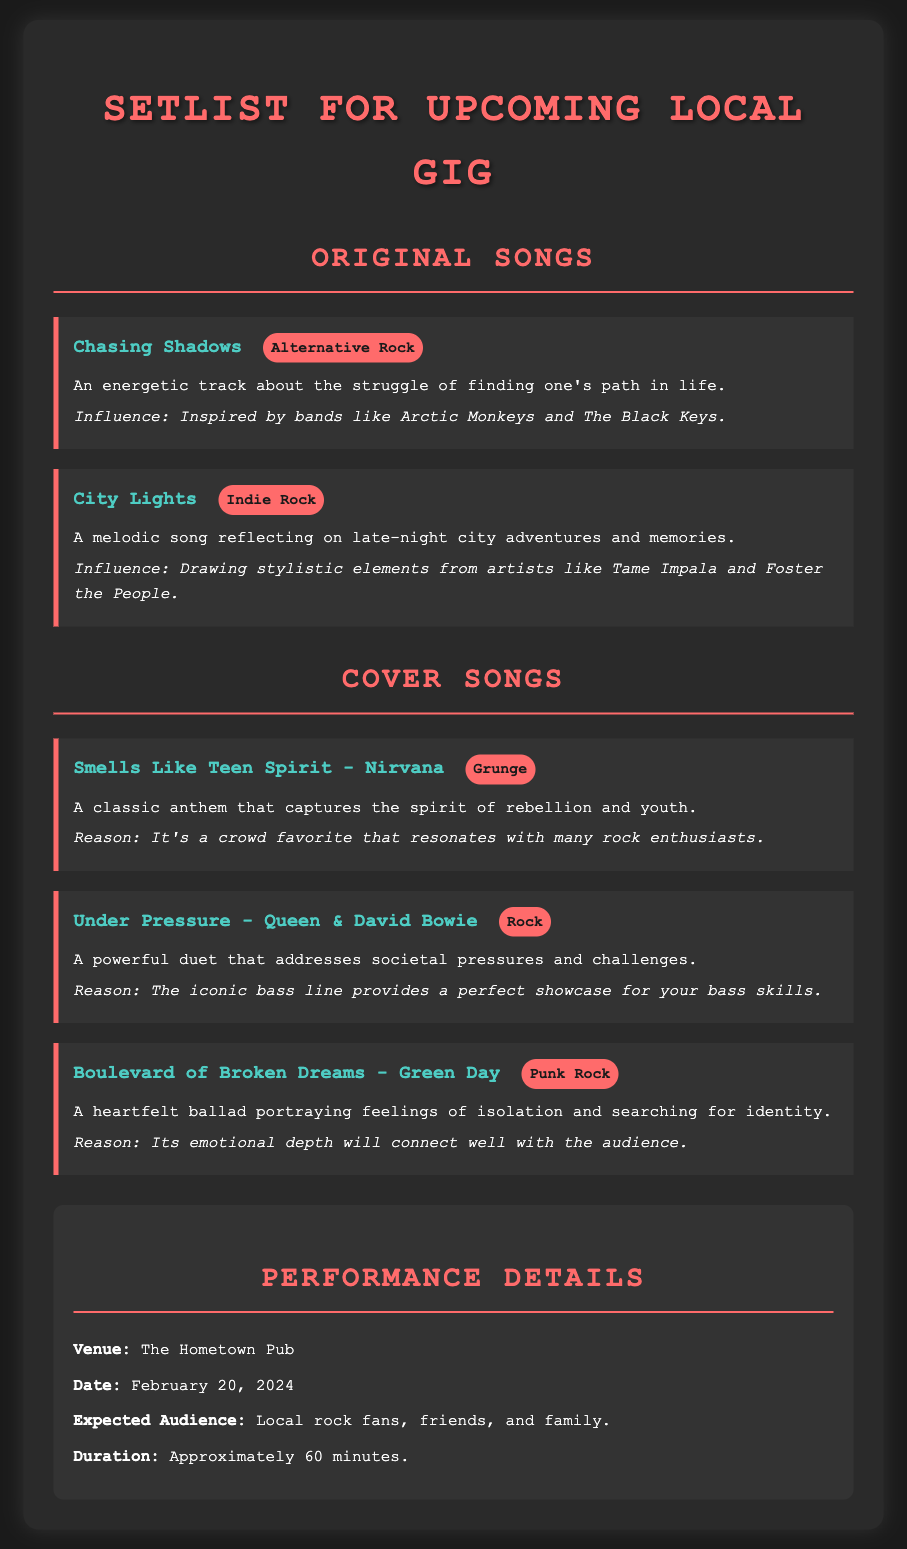What is the venue for the gig? The venue is mentioned in the performance details section of the document.
Answer: The Hometown Pub What is the date of the upcoming gig? The date is specified in the performance details section of the document.
Answer: February 20, 2024 How long is the performance expected to last? The duration of the performance is included in the performance details section.
Answer: Approximately 60 minutes Which song is listed as an original with an Alternative Rock genre? The songs are categorized into original songs and cover songs, and the specified genre is found in the original songs section.
Answer: Chasing Shadows What is the reason for including "Under Pressure" in the setlist? The reasoning behind selecting the song is mentioned in the cover songs section of the document.
Answer: The iconic bass line provides a perfect showcase for your bass skills Which band is associated with the cover song "Smells Like Teen Spirit"? The band performing the cover song is indicated next to the song title in the document.
Answer: Nirvana 